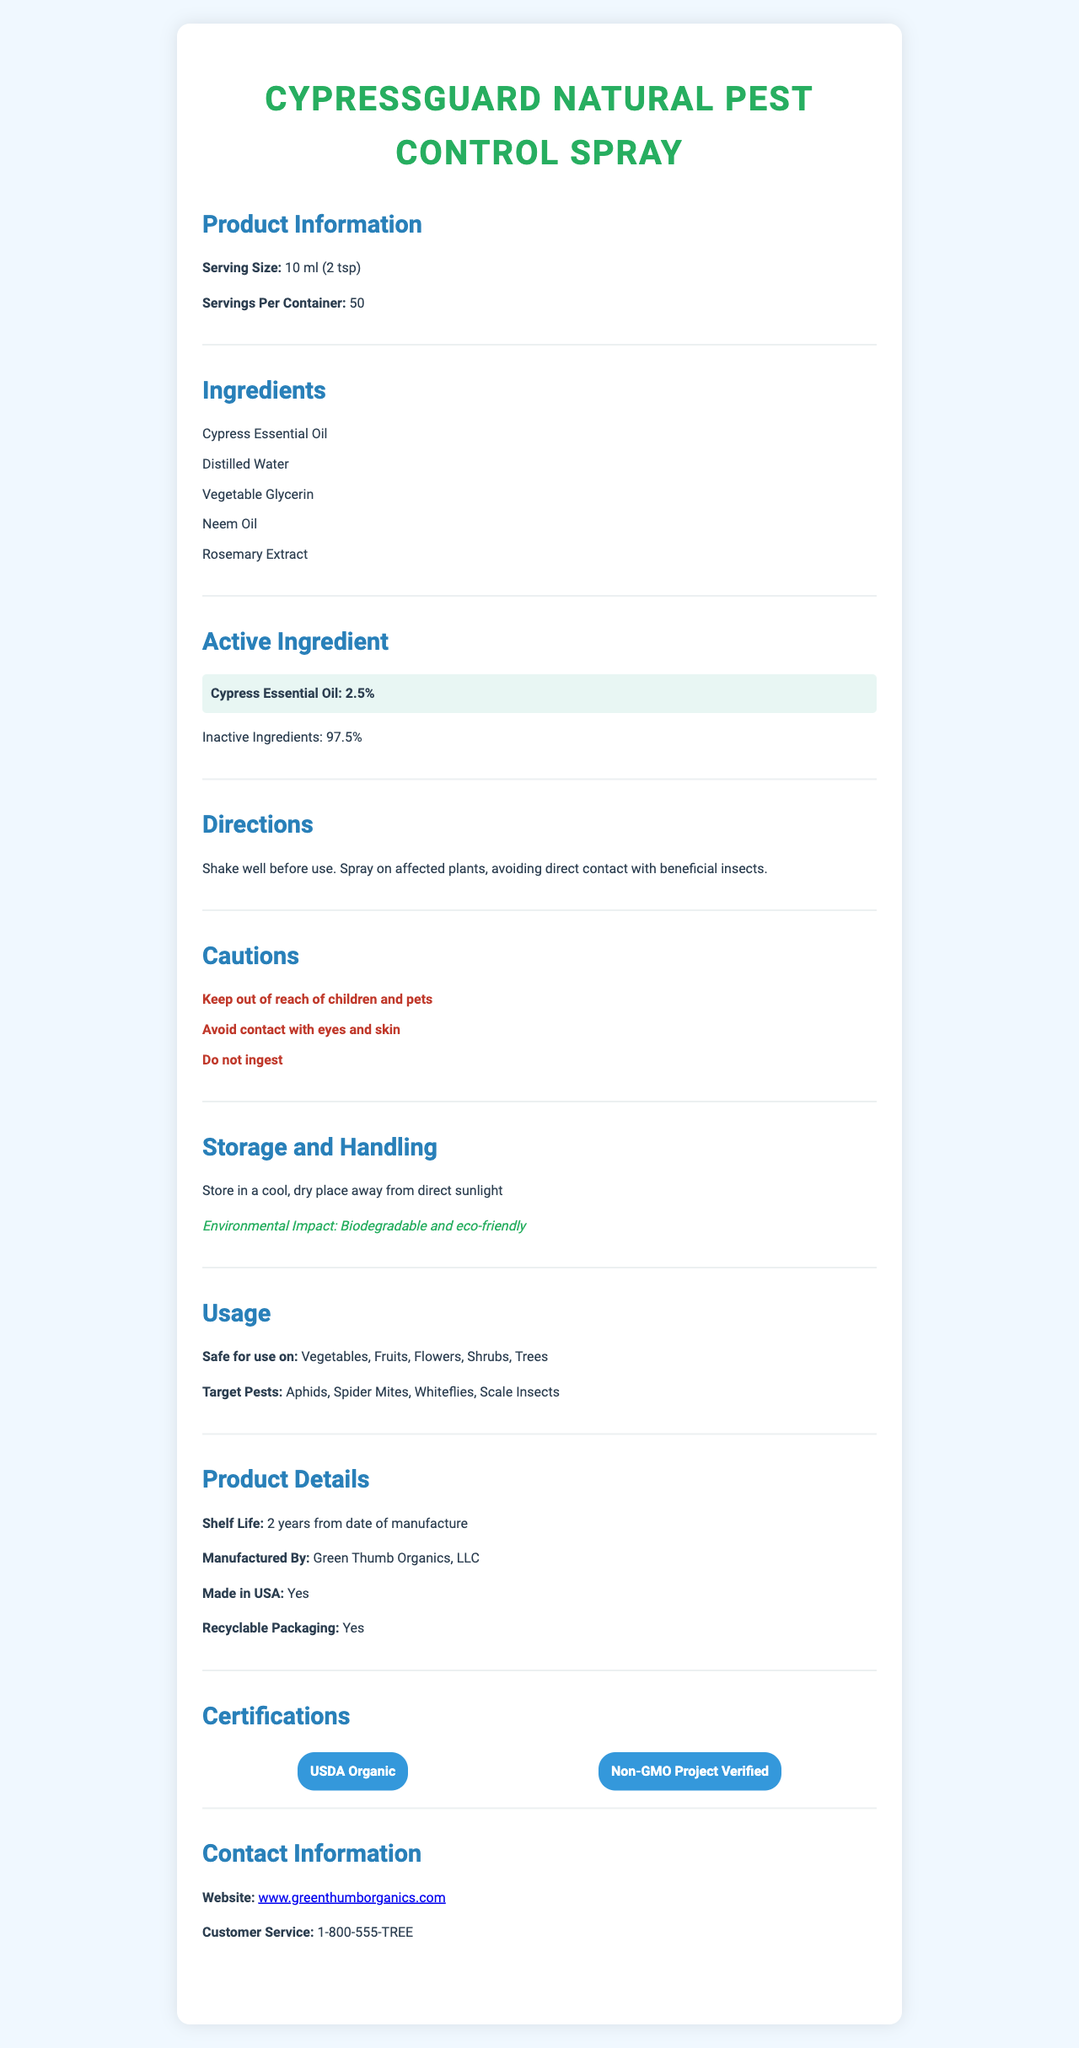What is the serving size of CypressGuard Natural Pest Control Spray? The serving size is stated in the "Product Information" section.
Answer: 10 ml (2 tsp) How many servings are there per container of CypressGuard Natural Pest Control Spray? The number of servings per container is mentioned in the "Product Information" section.
Answer: 50 What is the active ingredient and its concentration in CypressGuard Natural Pest Control Spray? The active ingredient and its concentration are highlighted in the "Active Ingredient" section.
Answer: Cypress Essential Oil, 2.5% What are the main ingredients in CypressGuard Natural Pest Control Spray? The ingredients are listed in the "Ingredients" section.
Answer: Cypress Essential Oil, Distilled Water, Vegetable Glycerin, Neem Oil, Rosemary Extract Which pests does CypressGuard Natural Pest Control Spray target? The target pests are listed in the "Usage" section.
Answer: Aphids, Spider Mites, Whiteflies, Scale Insects What is the shelf life of CypressGuard Natural Pest Control Spray? The shelf life is mentioned in the "Product Details" section.
Answer: 2 years from the date of manufacture Which certifications does CypressGuard Natural Pest Control Spray have? The certifications are mentioned in the "Certifications" section.
Answer: USDA Organic, Non-GMO Project Verified Which plants is CypressGuard Natural Pest Control Spray safe to use on? The safe usage on plants is detailed in the "Usage" section.
Answer: Vegetables, Fruits, Flowers, Shrubs, Trees What type of packaging does CypressGuard Natural Pest Control Spray use? This information is provided in the "Product Details" section.
Answer: Recyclable packaging How should you store CypressGuard Natural Pest Control Spray? Storage instructions are presented in the "Storage and Handling" section.
Answer: Store in a cool, dry place away from direct sunlight What should you do before using CypressGuard Natural Pest Control Spray? Directions about shaking before use are in the "Directions" section.
Answer: Shake well before use What should you avoid when using CypressGuard Natural Pest Control Spray? This caution is included in the "Directions" section.
Answer: Avoid direct contact with beneficial insects Which company manufactures CypressGuard Natural Pest Control Spray? The manufacturer details are given in the "Product Details" section.
Answer: Green Thumb Organics, LLC Where is CypressGuard Natural Pest Control Spray made? A. USA B. Canada C. Mexico The document states "Made in USA" in the "Product Details" section.
Answer: A. USA How should you handle CypressGuard Natural Pest Control Spray if it gets in your eyes or on your skin? A. Wash immediately with water B. Seek medical attention C. Both A and B The document only states to avoid contact with eyes and skin but does not provide further instructions on handling such incidents.
Answer: Not enough information Is CypressGuard Natural Pest Control Spray biodegradable and eco-friendly? The environmental impact section states that it is biodegradable and eco-friendly.
Answer: Yes Can you ingest CypressGuard Natural Pest Control Spray? The document specifically mentions "Do not ingest" in the "Cautions" section.
Answer: No Summarize the main idea of the document. The document provides detailed information about the product's ingredients, usage, storage, safety precautions, and certifications, emphasizing its natural and eco-friendly properties.
Answer: CypressGuard Natural Pest Control Spray is a USDA Organic, non-GMO, eco-friendly pest control product made primarily from Cypress Essential Oil. It is safe for use on various plants and targets common pests like aphids and spider mites. The product is manufactured by Green Thumb Organics, LLC in the USA and comes in recyclable packaging with a shelf life of 2 years. Users should follow the provided directions and precautions for safe and effective use. What is the customer service number for CypressGuard Natural Pest Control Spray? The contact information is provided in the "Contact Information" section.
Answer: 1-800-555-TREE Is CypressGuard Natural Pest Control Spray safe for use on pets? The document does not mention whether the spray is safe for pets; it only specifies keeping it out of reach of children and pets under cautions.
Answer: Not enough information 